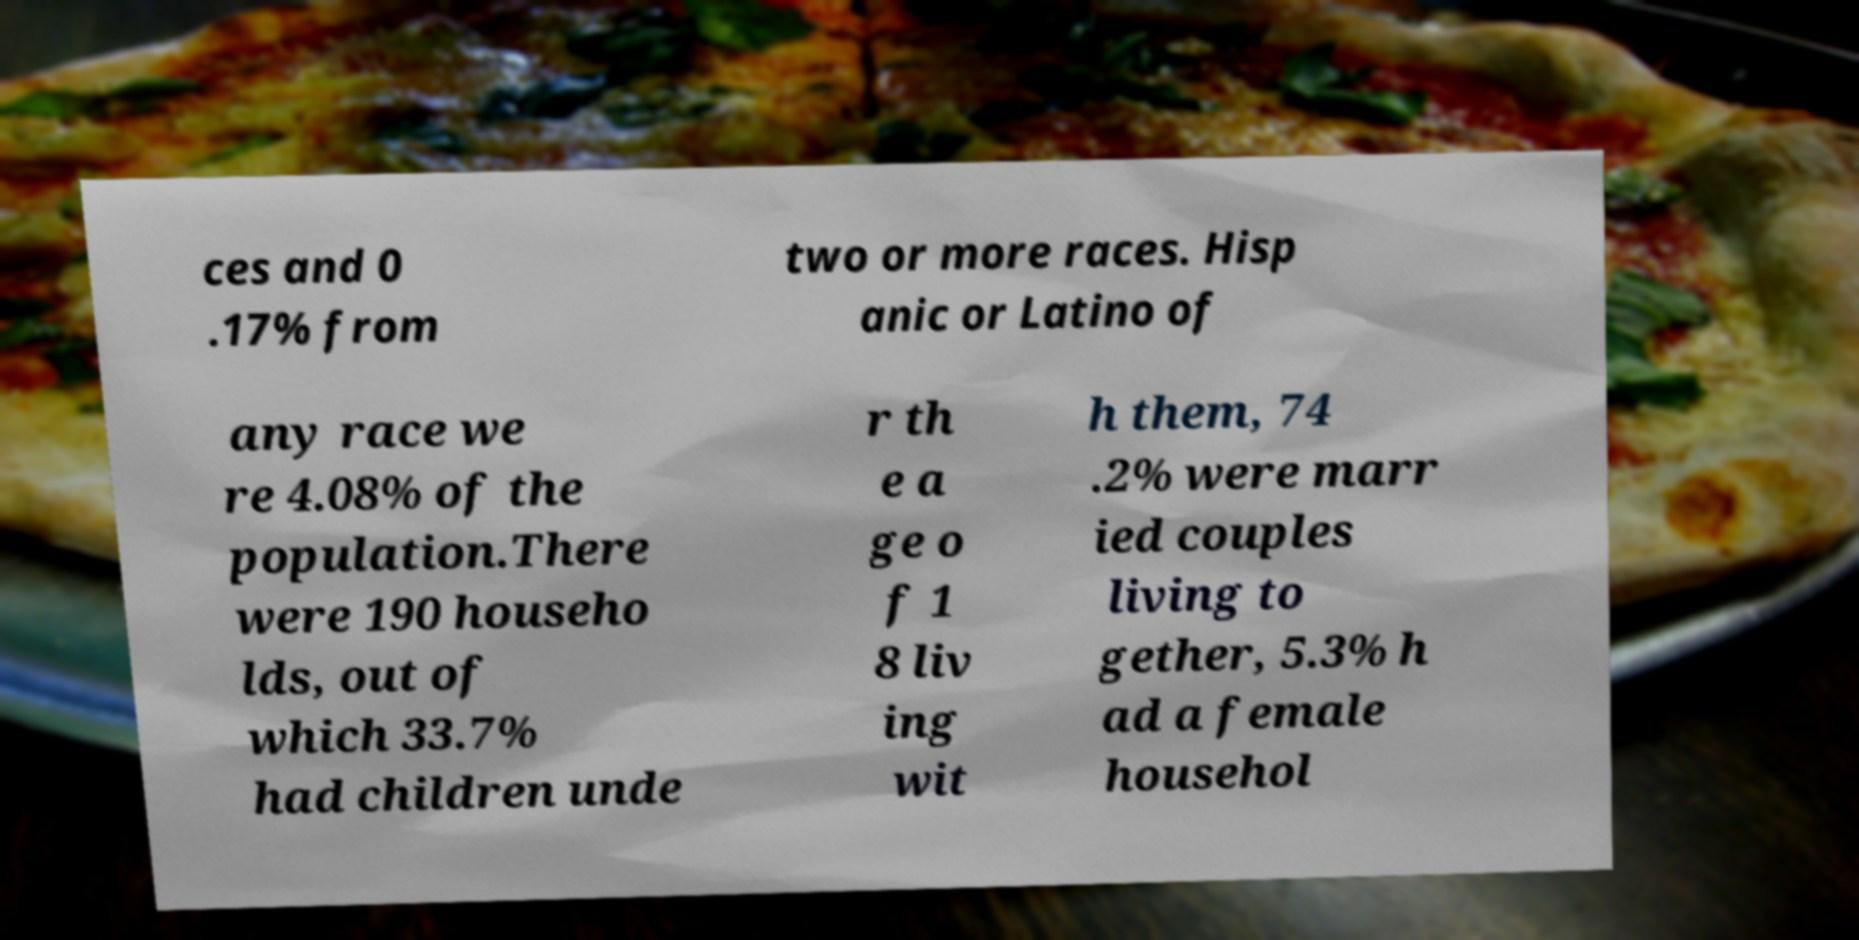Can you read and provide the text displayed in the image?This photo seems to have some interesting text. Can you extract and type it out for me? ces and 0 .17% from two or more races. Hisp anic or Latino of any race we re 4.08% of the population.There were 190 househo lds, out of which 33.7% had children unde r th e a ge o f 1 8 liv ing wit h them, 74 .2% were marr ied couples living to gether, 5.3% h ad a female househol 